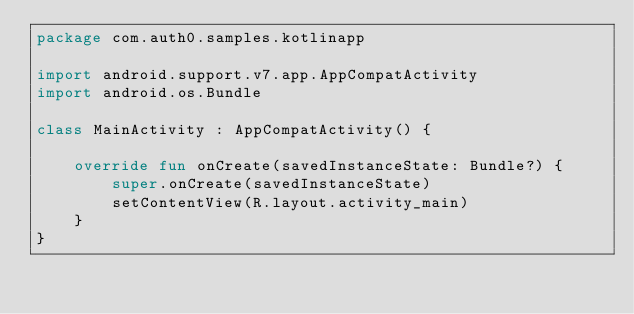Convert code to text. <code><loc_0><loc_0><loc_500><loc_500><_Kotlin_>package com.auth0.samples.kotlinapp

import android.support.v7.app.AppCompatActivity
import android.os.Bundle

class MainActivity : AppCompatActivity() {

    override fun onCreate(savedInstanceState: Bundle?) {
        super.onCreate(savedInstanceState)
        setContentView(R.layout.activity_main)
    }
}
</code> 